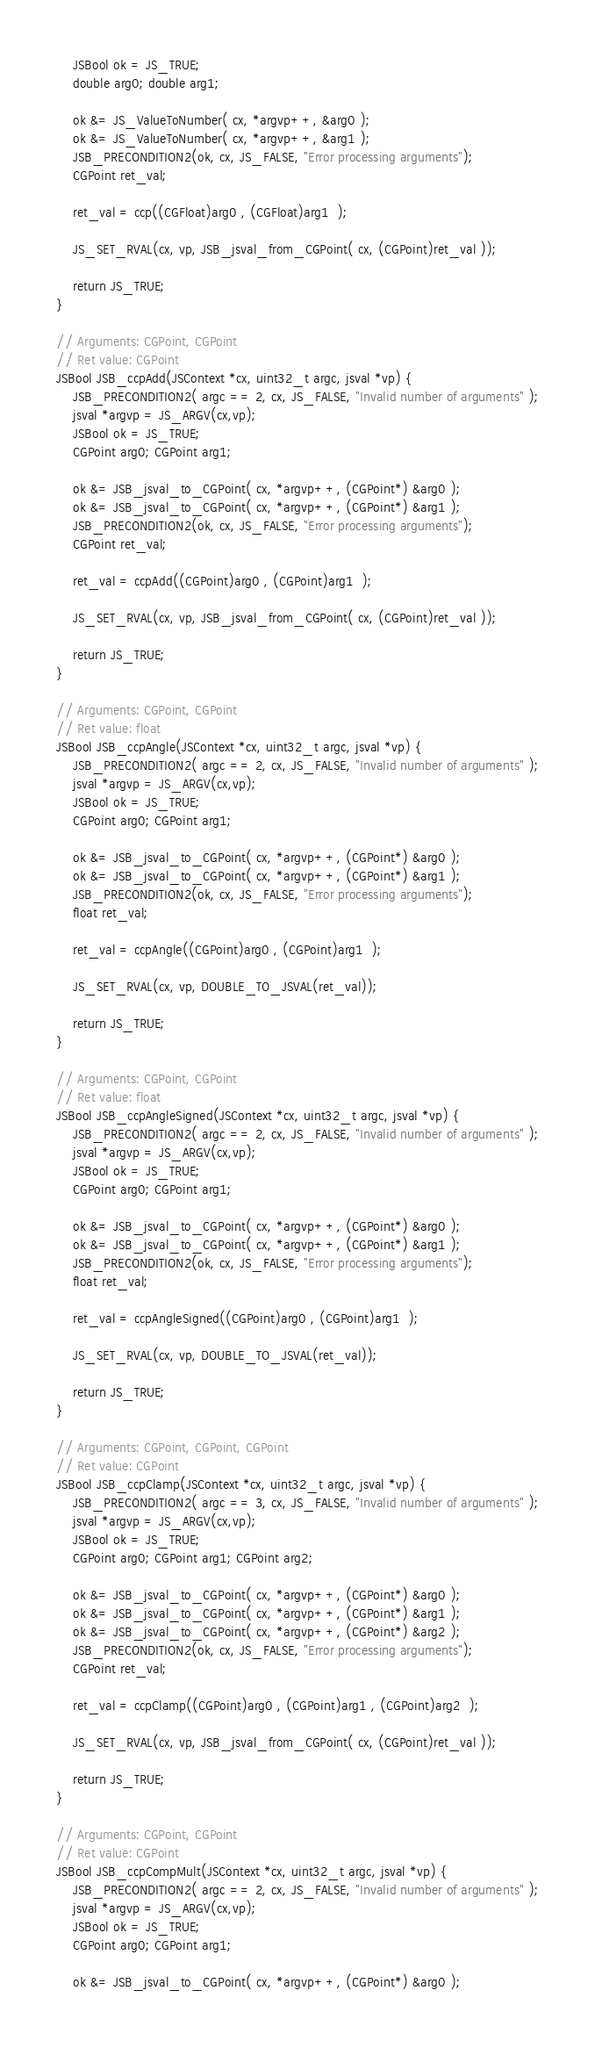Convert code to text. <code><loc_0><loc_0><loc_500><loc_500><_ObjectiveC_>	JSBool ok = JS_TRUE;
	double arg0; double arg1; 

	ok &= JS_ValueToNumber( cx, *argvp++, &arg0 );
	ok &= JS_ValueToNumber( cx, *argvp++, &arg1 );
	JSB_PRECONDITION2(ok, cx, JS_FALSE, "Error processing arguments");
	CGPoint ret_val;

	ret_val = ccp((CGFloat)arg0 , (CGFloat)arg1  );

	JS_SET_RVAL(cx, vp, JSB_jsval_from_CGPoint( cx, (CGPoint)ret_val ));

	return JS_TRUE;
}

// Arguments: CGPoint, CGPoint
// Ret value: CGPoint
JSBool JSB_ccpAdd(JSContext *cx, uint32_t argc, jsval *vp) {
	JSB_PRECONDITION2( argc == 2, cx, JS_FALSE, "Invalid number of arguments" );
	jsval *argvp = JS_ARGV(cx,vp);
	JSBool ok = JS_TRUE;
	CGPoint arg0; CGPoint arg1; 

	ok &= JSB_jsval_to_CGPoint( cx, *argvp++, (CGPoint*) &arg0 );
	ok &= JSB_jsval_to_CGPoint( cx, *argvp++, (CGPoint*) &arg1 );
	JSB_PRECONDITION2(ok, cx, JS_FALSE, "Error processing arguments");
	CGPoint ret_val;

	ret_val = ccpAdd((CGPoint)arg0 , (CGPoint)arg1  );

	JS_SET_RVAL(cx, vp, JSB_jsval_from_CGPoint( cx, (CGPoint)ret_val ));

	return JS_TRUE;
}

// Arguments: CGPoint, CGPoint
// Ret value: float
JSBool JSB_ccpAngle(JSContext *cx, uint32_t argc, jsval *vp) {
	JSB_PRECONDITION2( argc == 2, cx, JS_FALSE, "Invalid number of arguments" );
	jsval *argvp = JS_ARGV(cx,vp);
	JSBool ok = JS_TRUE;
	CGPoint arg0; CGPoint arg1; 

	ok &= JSB_jsval_to_CGPoint( cx, *argvp++, (CGPoint*) &arg0 );
	ok &= JSB_jsval_to_CGPoint( cx, *argvp++, (CGPoint*) &arg1 );
	JSB_PRECONDITION2(ok, cx, JS_FALSE, "Error processing arguments");
	float ret_val;

	ret_val = ccpAngle((CGPoint)arg0 , (CGPoint)arg1  );

	JS_SET_RVAL(cx, vp, DOUBLE_TO_JSVAL(ret_val));

	return JS_TRUE;
}

// Arguments: CGPoint, CGPoint
// Ret value: float
JSBool JSB_ccpAngleSigned(JSContext *cx, uint32_t argc, jsval *vp) {
	JSB_PRECONDITION2( argc == 2, cx, JS_FALSE, "Invalid number of arguments" );
	jsval *argvp = JS_ARGV(cx,vp);
	JSBool ok = JS_TRUE;
	CGPoint arg0; CGPoint arg1; 

	ok &= JSB_jsval_to_CGPoint( cx, *argvp++, (CGPoint*) &arg0 );
	ok &= JSB_jsval_to_CGPoint( cx, *argvp++, (CGPoint*) &arg1 );
	JSB_PRECONDITION2(ok, cx, JS_FALSE, "Error processing arguments");
	float ret_val;

	ret_val = ccpAngleSigned((CGPoint)arg0 , (CGPoint)arg1  );

	JS_SET_RVAL(cx, vp, DOUBLE_TO_JSVAL(ret_val));

	return JS_TRUE;
}

// Arguments: CGPoint, CGPoint, CGPoint
// Ret value: CGPoint
JSBool JSB_ccpClamp(JSContext *cx, uint32_t argc, jsval *vp) {
	JSB_PRECONDITION2( argc == 3, cx, JS_FALSE, "Invalid number of arguments" );
	jsval *argvp = JS_ARGV(cx,vp);
	JSBool ok = JS_TRUE;
	CGPoint arg0; CGPoint arg1; CGPoint arg2; 

	ok &= JSB_jsval_to_CGPoint( cx, *argvp++, (CGPoint*) &arg0 );
	ok &= JSB_jsval_to_CGPoint( cx, *argvp++, (CGPoint*) &arg1 );
	ok &= JSB_jsval_to_CGPoint( cx, *argvp++, (CGPoint*) &arg2 );
	JSB_PRECONDITION2(ok, cx, JS_FALSE, "Error processing arguments");
	CGPoint ret_val;

	ret_val = ccpClamp((CGPoint)arg0 , (CGPoint)arg1 , (CGPoint)arg2  );

	JS_SET_RVAL(cx, vp, JSB_jsval_from_CGPoint( cx, (CGPoint)ret_val ));

	return JS_TRUE;
}

// Arguments: CGPoint, CGPoint
// Ret value: CGPoint
JSBool JSB_ccpCompMult(JSContext *cx, uint32_t argc, jsval *vp) {
	JSB_PRECONDITION2( argc == 2, cx, JS_FALSE, "Invalid number of arguments" );
	jsval *argvp = JS_ARGV(cx,vp);
	JSBool ok = JS_TRUE;
	CGPoint arg0; CGPoint arg1; 

	ok &= JSB_jsval_to_CGPoint( cx, *argvp++, (CGPoint*) &arg0 );</code> 